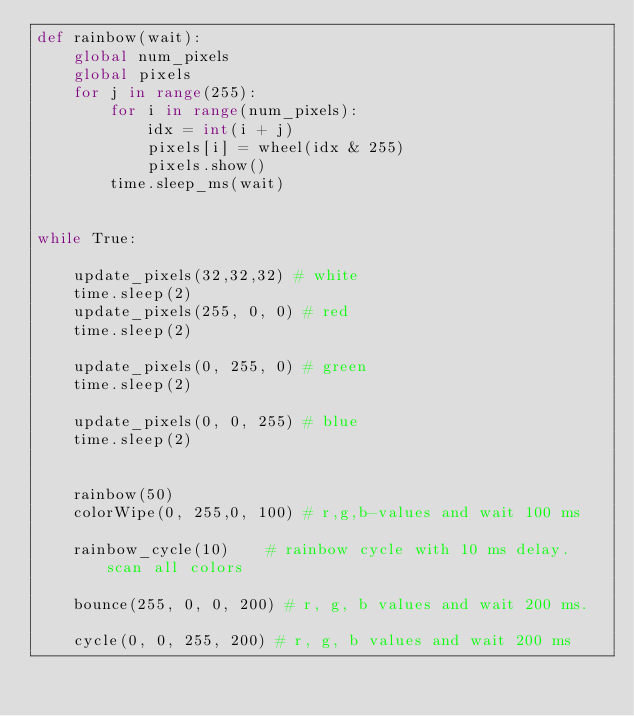Convert code to text. <code><loc_0><loc_0><loc_500><loc_500><_Python_>def rainbow(wait):
    global num_pixels
    global pixels
    for j in range(255):
        for i in range(num_pixels):
            idx = int(i + j)
            pixels[i] = wheel(idx & 255)
            pixels.show()
        time.sleep_ms(wait)


while True:

    update_pixels(32,32,32) # white
    time.sleep(2)
    update_pixels(255, 0, 0) # red
    time.sleep(2)

    update_pixels(0, 255, 0) # green
    time.sleep(2)

    update_pixels(0, 0, 255) # blue
    time.sleep(2)


    rainbow(50)
    colorWipe(0, 255,0, 100) # r,g,b-values and wait 100 ms

    rainbow_cycle(10)    # rainbow cycle with 10 ms delay. scan all colors

    bounce(255, 0, 0, 200) # r, g, b values and wait 200 ms.

    cycle(0, 0, 255, 200) # r, g, b values and wait 200 ms
</code> 